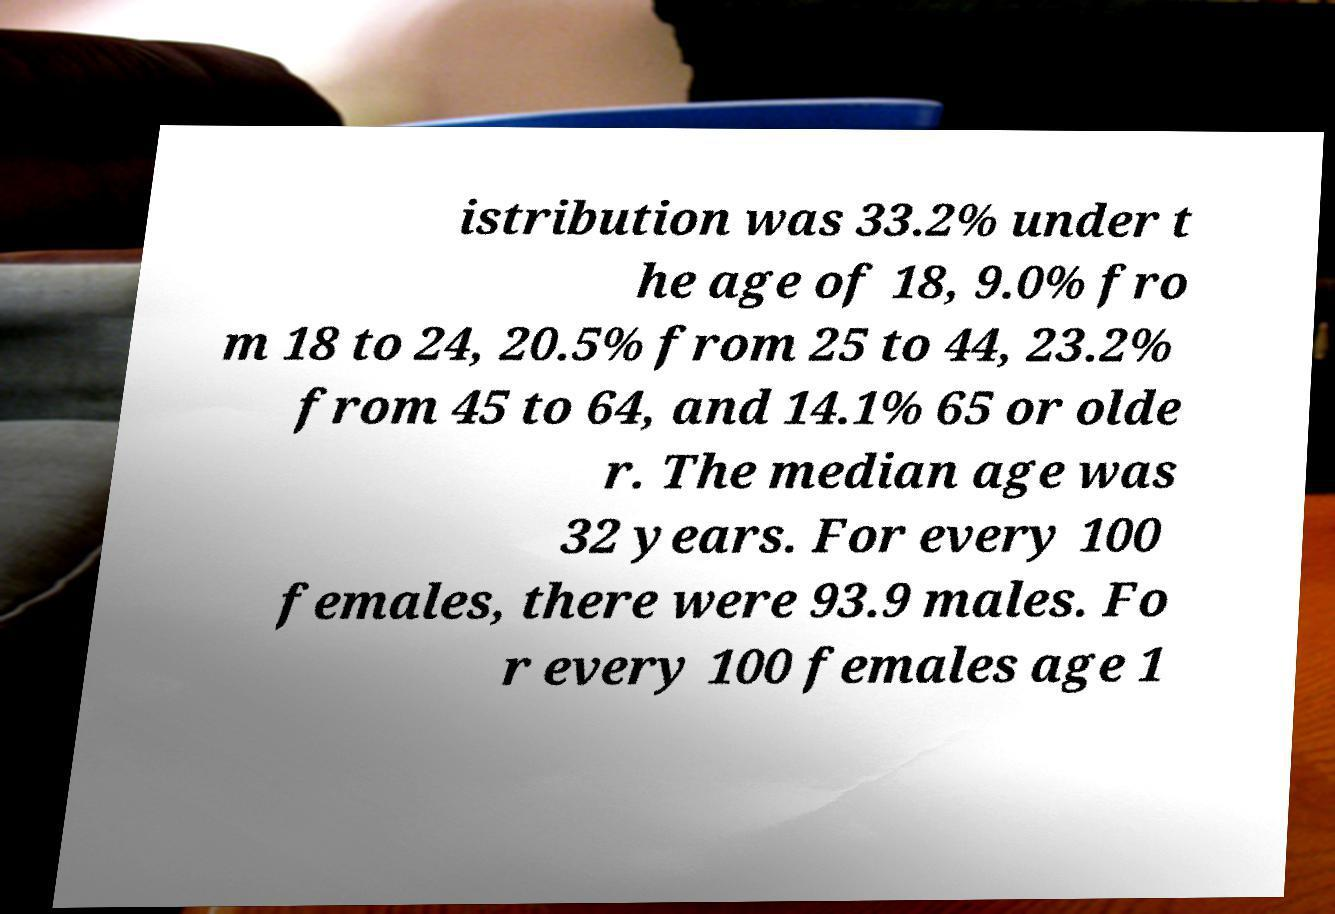There's text embedded in this image that I need extracted. Can you transcribe it verbatim? istribution was 33.2% under t he age of 18, 9.0% fro m 18 to 24, 20.5% from 25 to 44, 23.2% from 45 to 64, and 14.1% 65 or olde r. The median age was 32 years. For every 100 females, there were 93.9 males. Fo r every 100 females age 1 